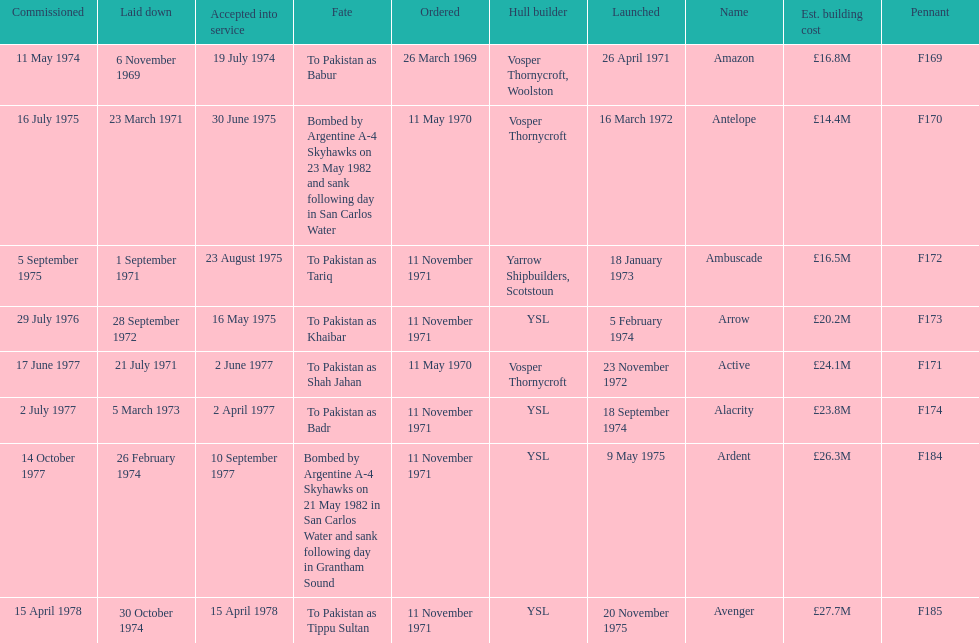The arrow was ordered on november 11, 1971. what was the previous ship? Ambuscade. 